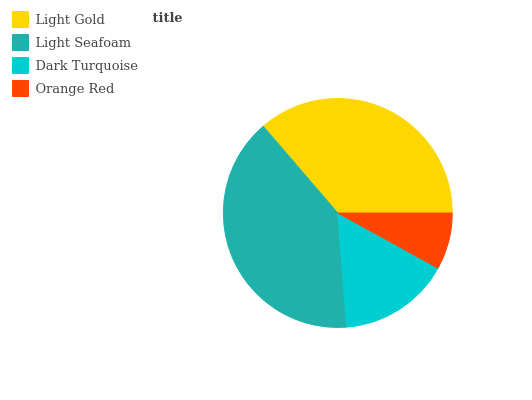Is Orange Red the minimum?
Answer yes or no. Yes. Is Light Seafoam the maximum?
Answer yes or no. Yes. Is Dark Turquoise the minimum?
Answer yes or no. No. Is Dark Turquoise the maximum?
Answer yes or no. No. Is Light Seafoam greater than Dark Turquoise?
Answer yes or no. Yes. Is Dark Turquoise less than Light Seafoam?
Answer yes or no. Yes. Is Dark Turquoise greater than Light Seafoam?
Answer yes or no. No. Is Light Seafoam less than Dark Turquoise?
Answer yes or no. No. Is Light Gold the high median?
Answer yes or no. Yes. Is Dark Turquoise the low median?
Answer yes or no. Yes. Is Dark Turquoise the high median?
Answer yes or no. No. Is Light Seafoam the low median?
Answer yes or no. No. 